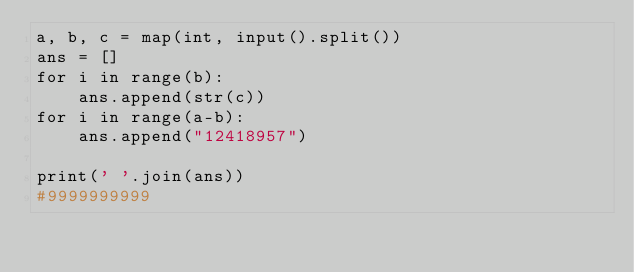Convert code to text. <code><loc_0><loc_0><loc_500><loc_500><_Python_>a, b, c = map(int, input().split())
ans = []
for i in range(b):
    ans.append(str(c))
for i in range(a-b):
    ans.append("12418957")

print(' '.join(ans))
#9999999999</code> 